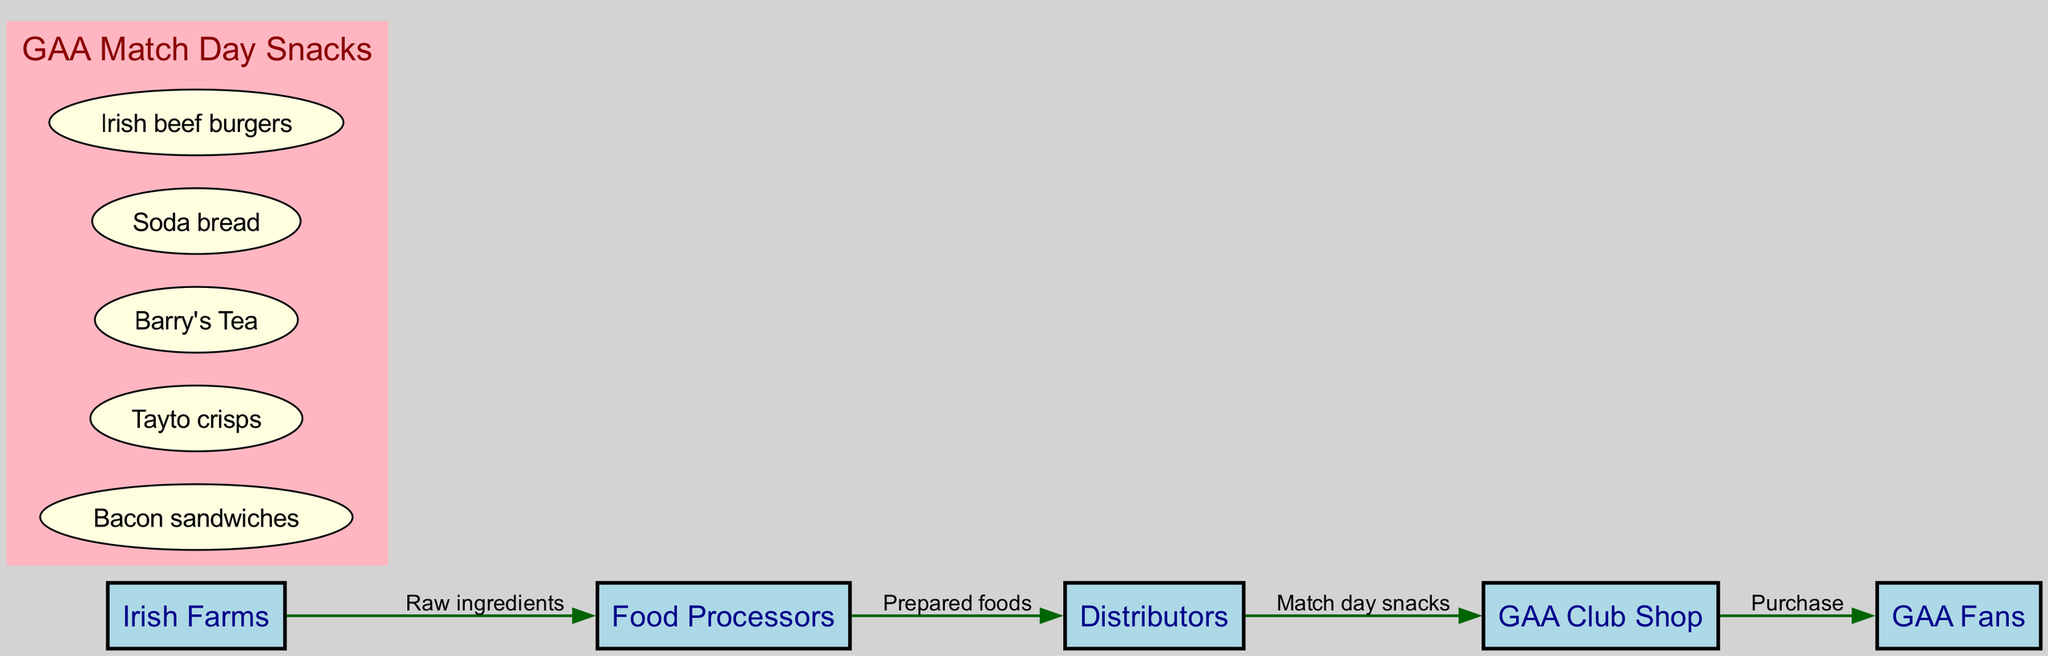What is the first entity in the food chain? The diagram begins with "Irish Farms," indicating it is the starting point of the food chain.
Answer: Irish Farms How many nodes are in the diagram? The diagram has five distinct nodes: Irish Farms, Food Processors, Distributors, GAA Club Shop, and GAA Fans. Counting these gives a total of five nodes.
Answer: 5 What type of snacks are supplied to the retailer? The edge between Distributors and GAA Club Shop is labeled as "Match day snacks," which specifies the type of products being supplied.
Answer: Match day snacks Who is the final consumer in the food chain? The last node, connected to the GAA Club Shop, is "GAA Fans," which identifies who ultimately consumes the products in this food chain.
Answer: GAA Fans Which products are included in the GAA Match Day Snacks category? The subgraph labeled "GAA Match Day Snacks" contains five products, namely Bacon sandwiches, Tayto crisps, Barry's Tea, Soda bread, and Irish beef burgers.
Answer: Bacon sandwiches, Tayto crisps, Barry's Tea, Soda bread, Irish beef burgers What is the flow of raw ingredients in the diagram? The flow starts at "Irish Farms" where raw ingredients originate and then they are processed into prepared foods by "Food Processors," creating a direct connection and moving down the chain.
Answer: From Irish Farms to Food Processors What links the consumer to the retailer? The relationship between GAA Fans and GAA Club Shop is described by the label "Purchase," indicating how consumers obtain the snacks from the retailer.
Answer: Purchase Which node connects processors to distributors? The edge labeled "Prepared foods" shows the connection between Food Processors and Distributors, indicating what is transferred between these two nodes.
Answer: Prepared foods 